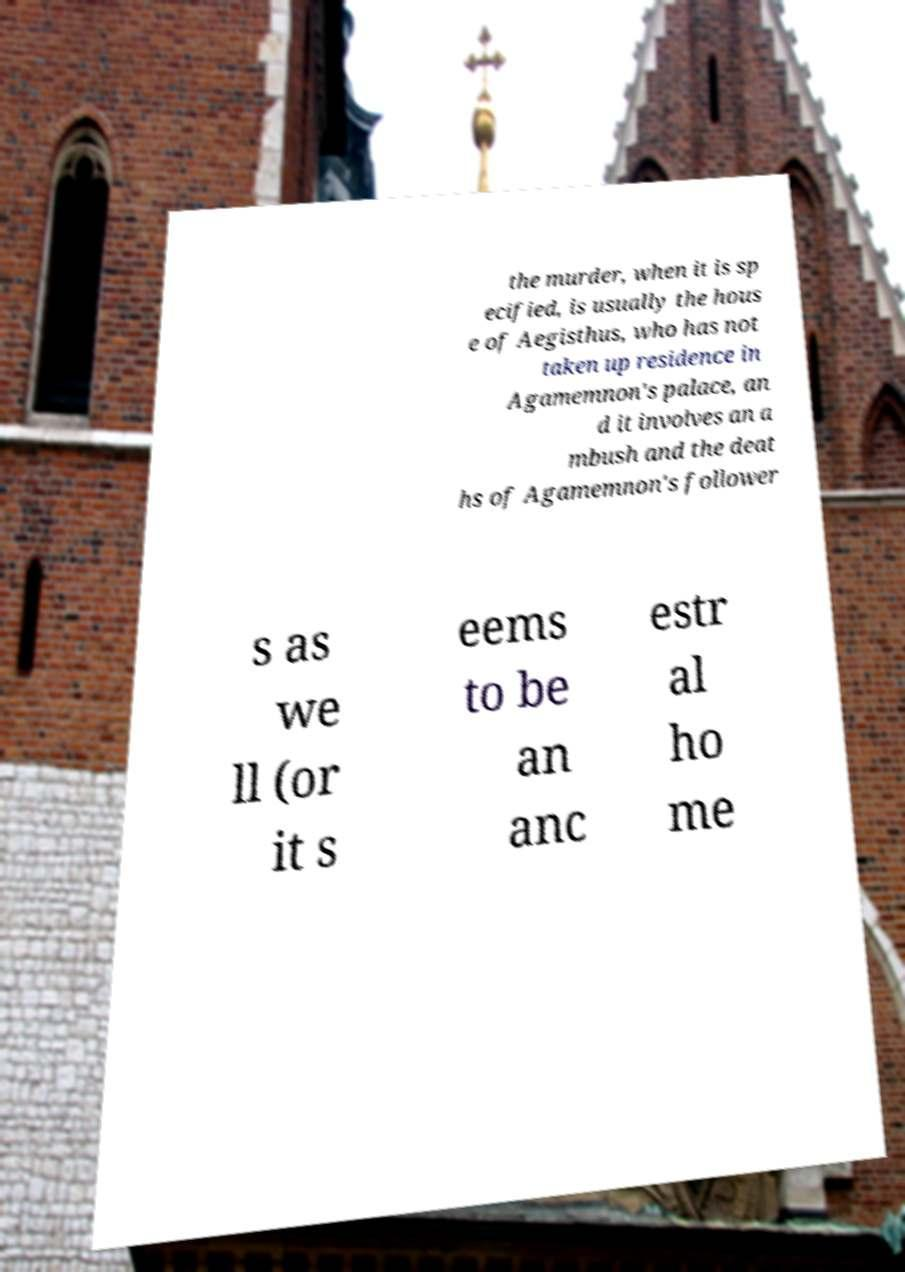I need the written content from this picture converted into text. Can you do that? the murder, when it is sp ecified, is usually the hous e of Aegisthus, who has not taken up residence in Agamemnon's palace, an d it involves an a mbush and the deat hs of Agamemnon's follower s as we ll (or it s eems to be an anc estr al ho me 